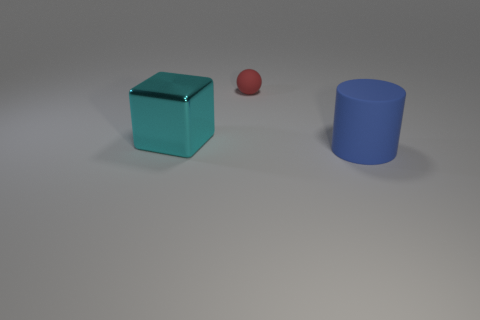Add 2 cyan things. How many objects exist? 5 Subtract all spheres. How many objects are left? 2 Add 2 gray cylinders. How many gray cylinders exist? 2 Subtract 0 purple cylinders. How many objects are left? 3 Subtract all tiny brown objects. Subtract all rubber cylinders. How many objects are left? 2 Add 2 cyan things. How many cyan things are left? 3 